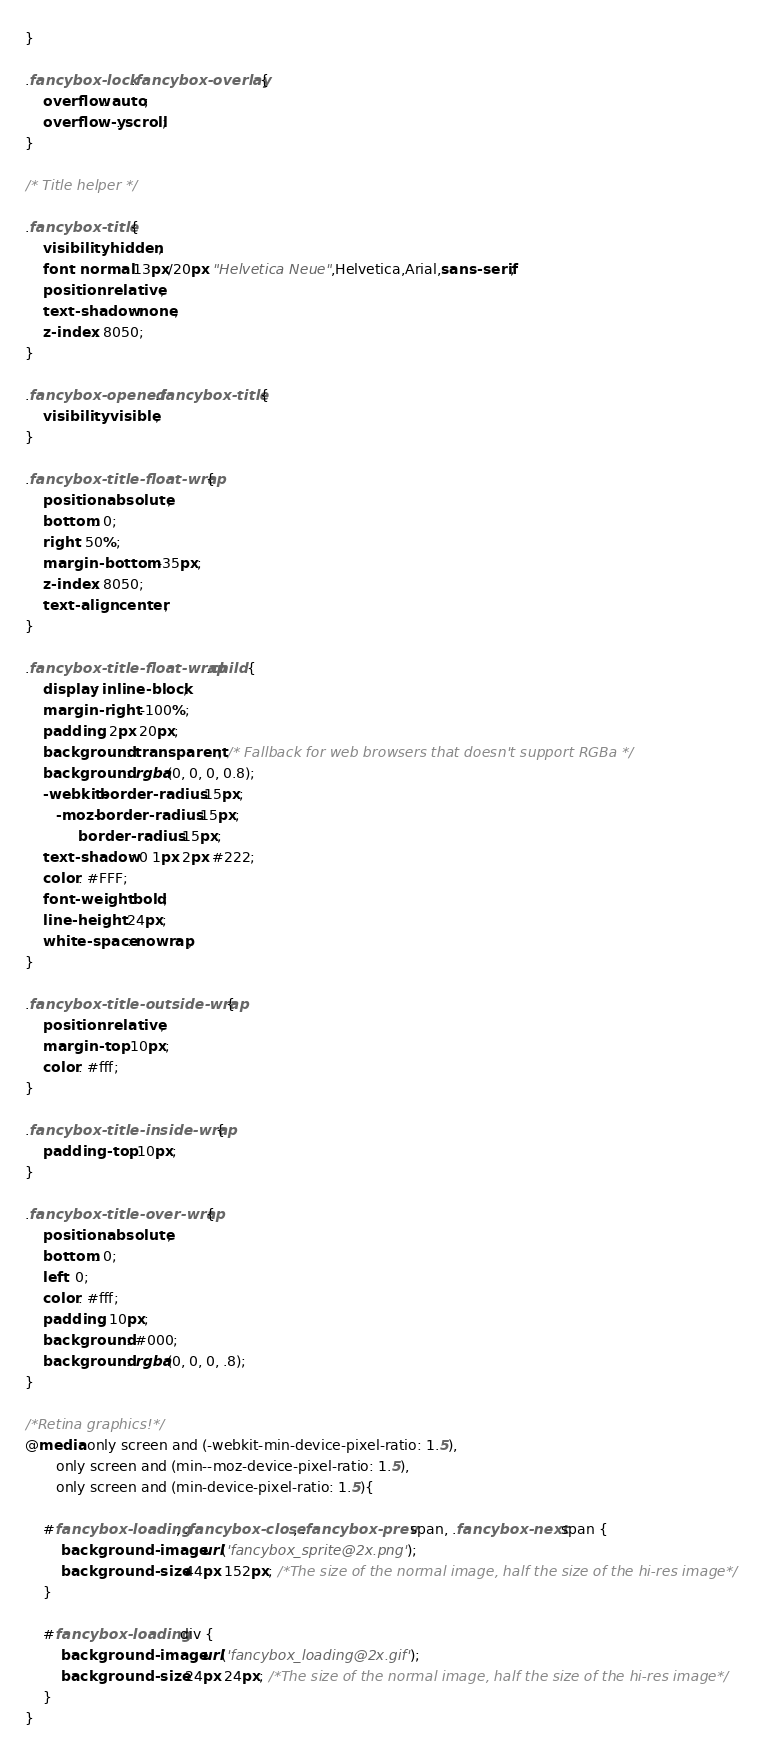Convert code to text. <code><loc_0><loc_0><loc_500><loc_500><_CSS_>}

.fancybox-lock .fancybox-overlay {
	overflow: auto;
	overflow-y: scroll;
}

/* Title helper */

.fancybox-title {
	visibility: hidden;
	font: normal 13px/20px "Helvetica Neue",Helvetica,Arial,sans-serif;
	position: relative;
	text-shadow: none;
	z-index: 8050;
}

.fancybox-opened .fancybox-title {
	visibility: visible;
}

.fancybox-title-float-wrap {
	position: absolute;
	bottom: 0;
	right: 50%;
	margin-bottom: -35px;
	z-index: 8050;
	text-align: center;
}

.fancybox-title-float-wrap .child {
	display: inline-block;
	margin-right: -100%;
	padding: 2px 20px;
	background: transparent; /* Fallback for web browsers that doesn't support RGBa */
	background: rgba(0, 0, 0, 0.8);
	-webkit-border-radius: 15px;
	   -moz-border-radius: 15px;
	        border-radius: 15px;
	text-shadow: 0 1px 2px #222;
	color: #FFF;
	font-weight: bold;
	line-height: 24px;
	white-space: nowrap;
}

.fancybox-title-outside-wrap {
	position: relative;
	margin-top: 10px;
	color: #fff;
}

.fancybox-title-inside-wrap {
	padding-top: 10px;
}

.fancybox-title-over-wrap {
	position: absolute;
	bottom: 0;
	left: 0;
	color: #fff;
	padding: 10px;
	background: #000;
	background: rgba(0, 0, 0, .8);
}

/*Retina graphics!*/
@media only screen and (-webkit-min-device-pixel-ratio: 1.5),
	   only screen and (min--moz-device-pixel-ratio: 1.5),
	   only screen and (min-device-pixel-ratio: 1.5){

	#fancybox-loading, .fancybox-close, .fancybox-prev span, .fancybox-next span {
		background-image: url('fancybox_sprite@2x.png');
		background-size: 44px 152px; /*The size of the normal image, half the size of the hi-res image*/
	}

	#fancybox-loading div {
		background-image: url('fancybox_loading@2x.gif');
		background-size: 24px 24px; /*The size of the normal image, half the size of the hi-res image*/
	}
}</code> 